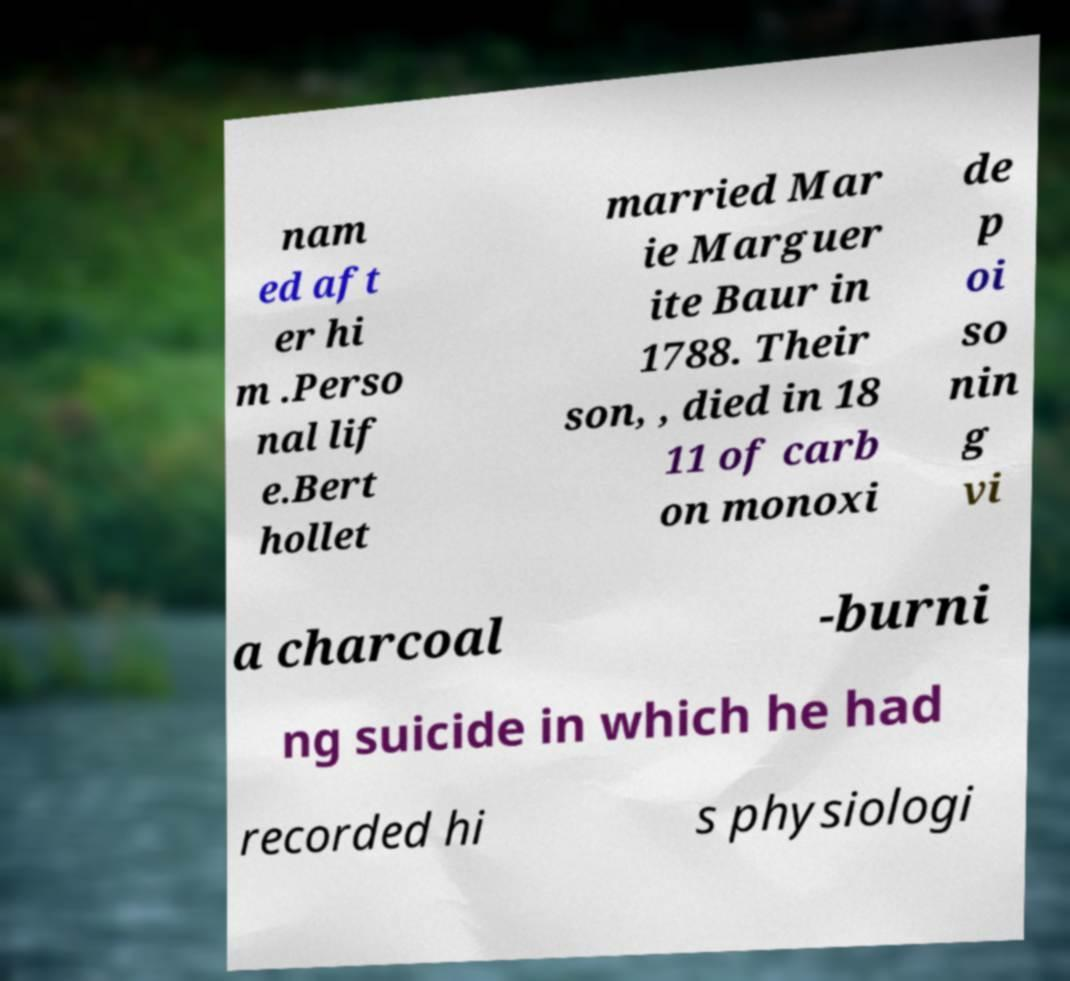Please identify and transcribe the text found in this image. nam ed aft er hi m .Perso nal lif e.Bert hollet married Mar ie Marguer ite Baur in 1788. Their son, , died in 18 11 of carb on monoxi de p oi so nin g vi a charcoal -burni ng suicide in which he had recorded hi s physiologi 